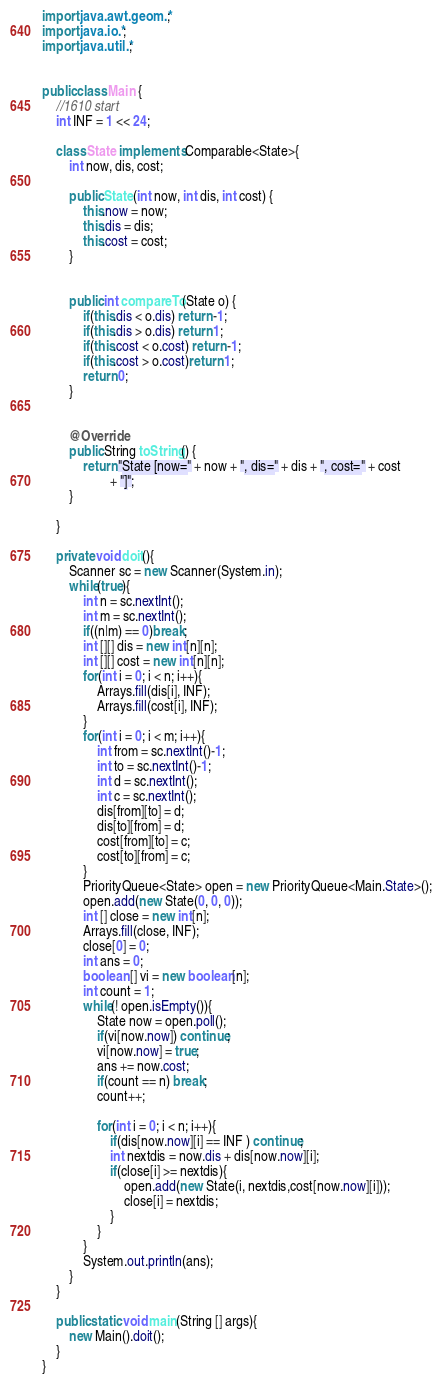<code> <loc_0><loc_0><loc_500><loc_500><_Java_>import java.awt.geom.*;
import java.io.*;
import java.util.*;


public class Main {
	//1610 start
	int INF = 1 << 24;
	
	class State implements Comparable<State>{
		int now, dis, cost;

		public State(int now, int dis, int cost) {
			this.now = now;
			this.dis = dis;
			this.cost = cost;
		}


		public int compareTo(State o) {
			if(this.dis < o.dis) return -1;
			if(this.dis > o.dis) return 1;
			if(this.cost < o.cost) return -1;
			if(this.cost > o.cost)return 1;
			return 0;
		}


		@Override
		public String toString() {
			return "State [now=" + now + ", dis=" + dis + ", cost=" + cost
					+ "]";
		}
		
	}
	
	private void doit(){
		Scanner sc = new Scanner(System.in);
		while(true){
			int n = sc.nextInt();
			int m = sc.nextInt();
			if((n|m) == 0)break;
			int [][] dis = new int[n][n];
			int [][] cost = new int[n][n];
			for(int i = 0; i < n; i++){
				Arrays.fill(dis[i], INF);
				Arrays.fill(cost[i], INF);
			}
			for(int i = 0; i < m; i++){
				int from = sc.nextInt()-1;
				int to = sc.nextInt()-1;
				int d = sc.nextInt();
				int c = sc.nextInt();
				dis[from][to] = d;
				dis[to][from] = d;
				cost[from][to] = c;
				cost[to][from] = c;
			}
			PriorityQueue<State> open = new PriorityQueue<Main.State>();
			open.add(new State(0, 0, 0));
			int [] close = new int[n];
			Arrays.fill(close, INF);
			close[0] = 0;
			int ans = 0;
			boolean [] vi = new boolean[n];
			int count = 1;
			while(! open.isEmpty()){
				State now = open.poll();
				if(vi[now.now]) continue;
				vi[now.now] = true;
				ans += now.cost;
				if(count == n) break;
				count++;
				
				for(int i = 0; i < n; i++){
					if(dis[now.now][i] == INF ) continue;
					int nextdis = now.dis + dis[now.now][i];
					if(close[i] >= nextdis){
						open.add(new State(i, nextdis,cost[now.now][i]));
						close[i] = nextdis;
					}
				}
			}
			System.out.println(ans);
		}
	}

	public static void main(String [] args){
		new Main().doit();
	}
}</code> 